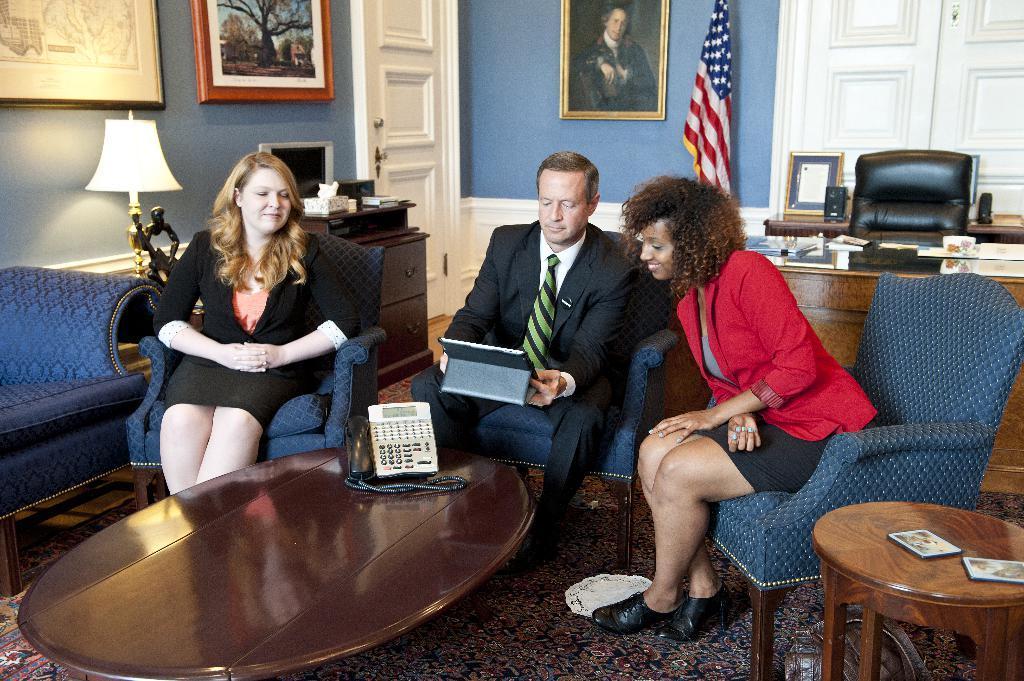Please provide a concise description of this image. There are two women sitting on the chair and a man is holding tab in his hand and sitting on the chair. Behind him there are frames on the wall,lamp,flag,table and a door. 